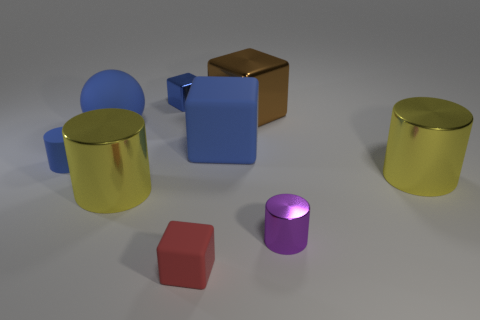How many large matte cubes have the same color as the rubber sphere?
Provide a succinct answer. 1. What is the color of the small rubber object that is the same shape as the purple metal object?
Make the answer very short. Blue. Is the size of the blue metal block the same as the purple cylinder?
Provide a succinct answer. Yes. What number of other objects are there of the same size as the purple metallic cylinder?
Your answer should be compact. 3. How many objects are yellow shiny cylinders that are on the right side of the small red block or objects that are to the left of the blue rubber sphere?
Your response must be concise. 2. There is a blue metal thing that is the same size as the blue matte cylinder; what shape is it?
Your response must be concise. Cube. There is a purple cylinder that is the same material as the big brown cube; what size is it?
Ensure brevity in your answer.  Small. Does the brown metal object have the same shape as the tiny red object?
Provide a succinct answer. Yes. There is a matte cube that is the same size as the purple cylinder; what is its color?
Make the answer very short. Red. The blue metal thing that is the same shape as the red object is what size?
Your response must be concise. Small. 